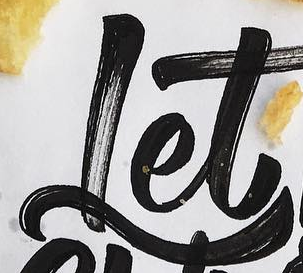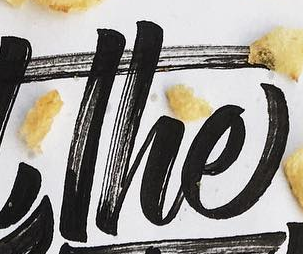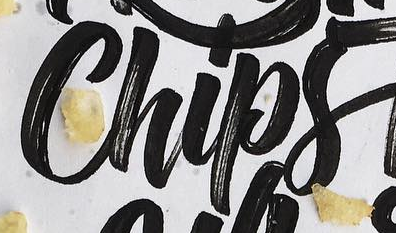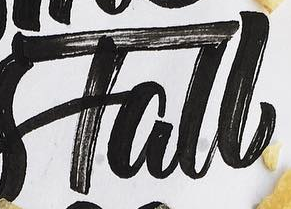What words are shown in these images in order, separated by a semicolon? Let; The; Chips; Tall 